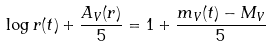Convert formula to latex. <formula><loc_0><loc_0><loc_500><loc_500>\log r ( t ) + \frac { A _ { V } ( r ) } { 5 } = 1 + \frac { m _ { V } ( t ) - M _ { V } } { 5 }</formula> 